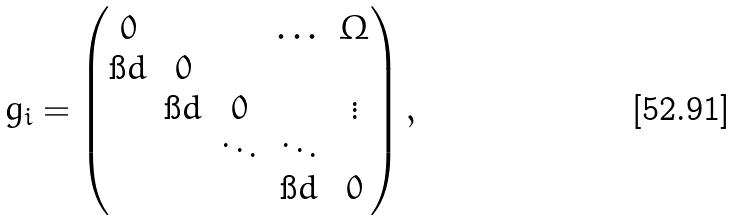<formula> <loc_0><loc_0><loc_500><loc_500>g _ { i } = \left ( \begin{matrix} 0 & & & \dots & \Omega \\ \i d & 0 & & & \\ & \i d & 0 & & \vdots \\ & & \ddots & \ddots & \\ & & & \i d & 0 \end{matrix} \right ) ,</formula> 